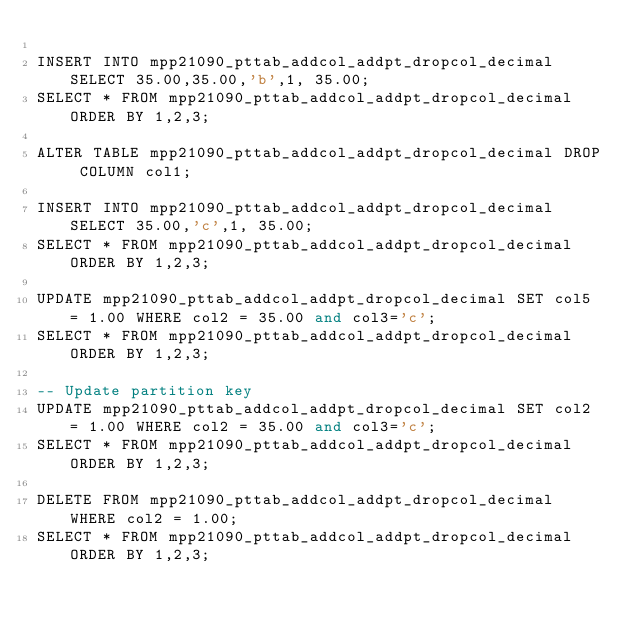Convert code to text. <code><loc_0><loc_0><loc_500><loc_500><_SQL_>
INSERT INTO mpp21090_pttab_addcol_addpt_dropcol_decimal SELECT 35.00,35.00,'b',1, 35.00;
SELECT * FROM mpp21090_pttab_addcol_addpt_dropcol_decimal ORDER BY 1,2,3;

ALTER TABLE mpp21090_pttab_addcol_addpt_dropcol_decimal DROP COLUMN col1;

INSERT INTO mpp21090_pttab_addcol_addpt_dropcol_decimal SELECT 35.00,'c',1, 35.00;
SELECT * FROM mpp21090_pttab_addcol_addpt_dropcol_decimal ORDER BY 1,2,3;

UPDATE mpp21090_pttab_addcol_addpt_dropcol_decimal SET col5 = 1.00 WHERE col2 = 35.00 and col3='c';
SELECT * FROM mpp21090_pttab_addcol_addpt_dropcol_decimal ORDER BY 1,2,3;

-- Update partition key
UPDATE mpp21090_pttab_addcol_addpt_dropcol_decimal SET col2 = 1.00 WHERE col2 = 35.00 and col3='c';
SELECT * FROM mpp21090_pttab_addcol_addpt_dropcol_decimal ORDER BY 1,2,3;

DELETE FROM mpp21090_pttab_addcol_addpt_dropcol_decimal WHERE col2 = 1.00;
SELECT * FROM mpp21090_pttab_addcol_addpt_dropcol_decimal ORDER BY 1,2,3;

</code> 